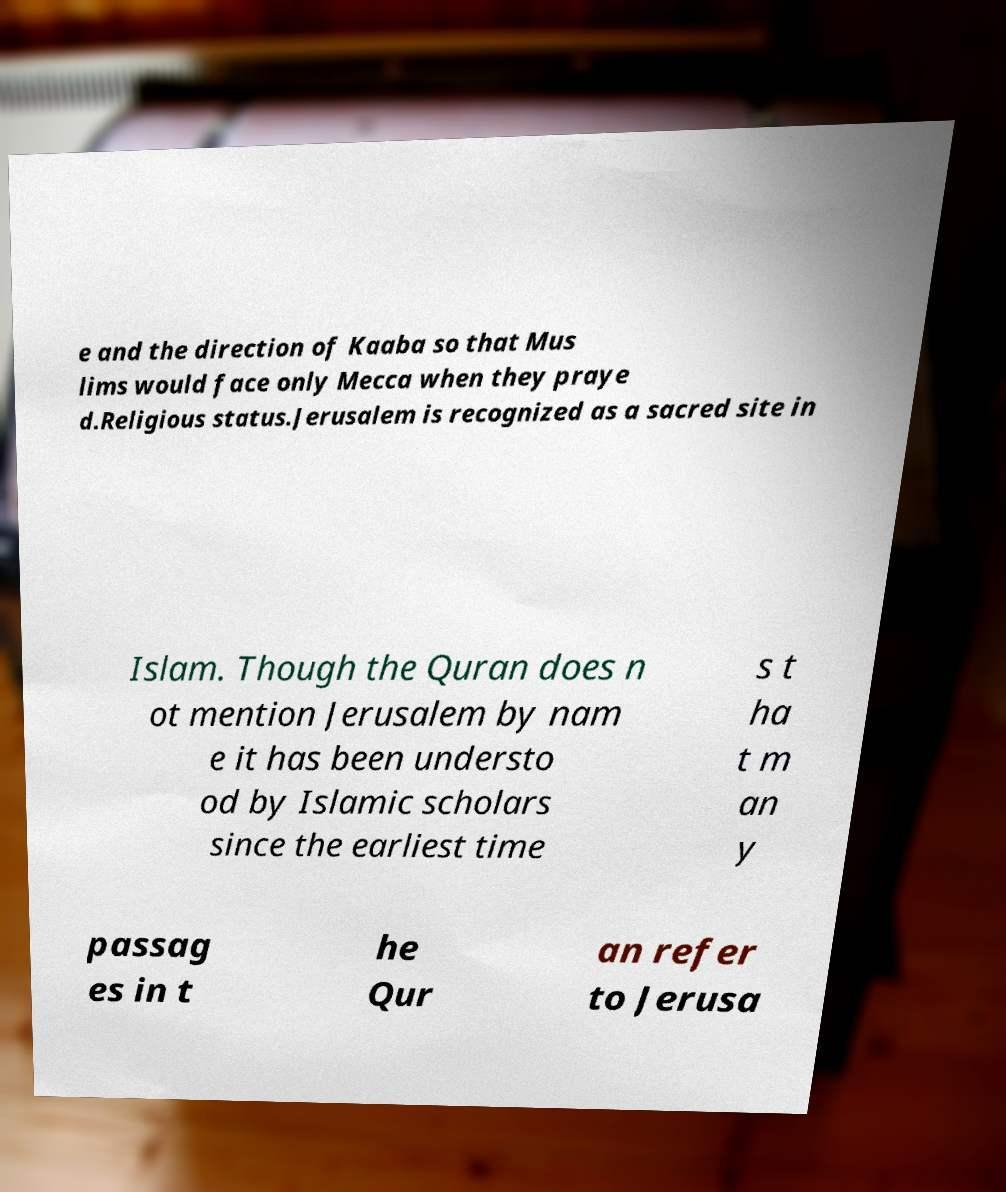Please identify and transcribe the text found in this image. e and the direction of Kaaba so that Mus lims would face only Mecca when they praye d.Religious status.Jerusalem is recognized as a sacred site in Islam. Though the Quran does n ot mention Jerusalem by nam e it has been understo od by Islamic scholars since the earliest time s t ha t m an y passag es in t he Qur an refer to Jerusa 